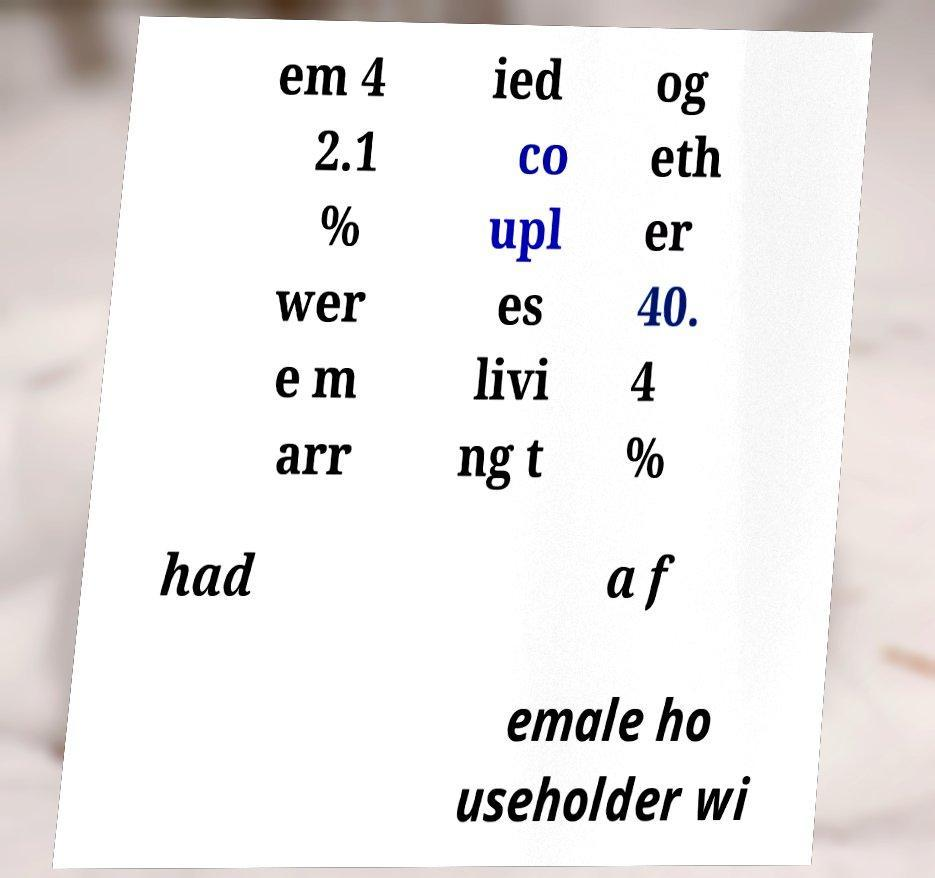Can you accurately transcribe the text from the provided image for me? em 4 2.1 % wer e m arr ied co upl es livi ng t og eth er 40. 4 % had a f emale ho useholder wi 